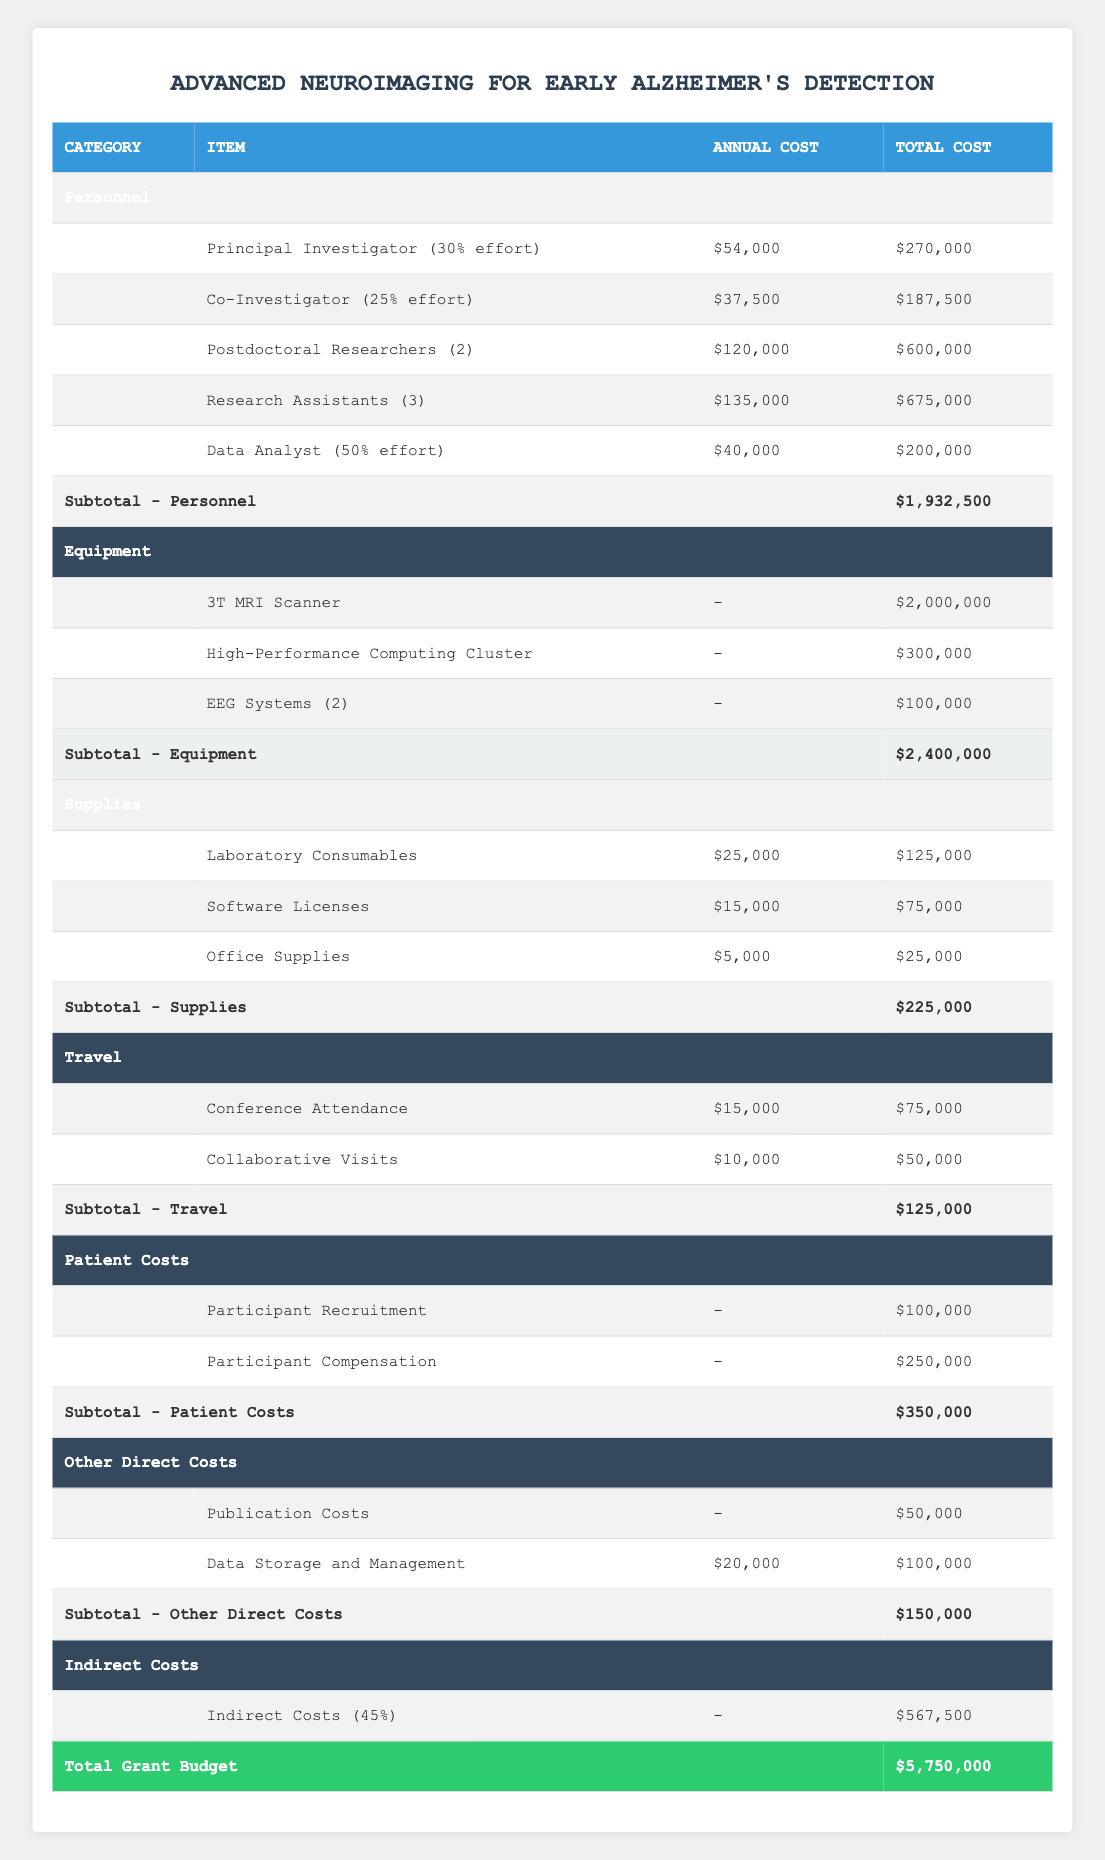what is the total budget for the grant proposal? The total budget is listed in the last row of the table under the "Total Grant Budget" heading. It states that the total budget is $5,750,000.
Answer: $5,750,000 how much is allocated for personnel costs? The subtotal for personnel costs is found in the Personnel section of the table. It indicates that the total allocated for personnel is $1,932,500.
Answer: $1,932,500 what percentage of the total budget does the Equipment category represent? The Equipment category total is $2,400,000. To find the percentage, divide the Equipment total by the total budget: (2,400,000 / 5,750,000) * 100 = 41.74%.
Answer: 41.74% does the budget include costs for participant recruitment? Yes, the budget includes an item for "Participant Recruitment" under the Patient Costs category, with a total cost of $100,000.
Answer: Yes what is the combined total for travel and patient costs? The total for travel is $125,000 and the total for patient costs is $350,000. Adding these figures gives: 125,000 + 350,000 = 475,000.
Answer: $475,000 how much more is spent on equipment compared to supplies? The total for Equipment is $2,400,000 while the total for Supplies is $225,000. The difference is calculated as: 2,400,000 - 225,000 = 2,175,000.
Answer: $2,175,000 which personnel role has the highest total cost? In the Personnel section, we can compare the total costs for each role. The Postdoctoral Researchers have a total cost of $600,000, which is the highest compared to other personnel roles.
Answer: Postdoctoral Researchers what is the total cost for software licenses? In the Supplies section, the total cost for Software Licenses is specifically listed as $75,000.
Answer: $75,000 if the indirect costs are 45% of the total budget, what is the dollar amount for indirect costs? The indirect costs are stated as 45% of the total budget, which is $5,750,000. To find it, calculate 5,750,000 * 0.45 = $567,500, which confirms the table's indirect costs entry.
Answer: $567,500 